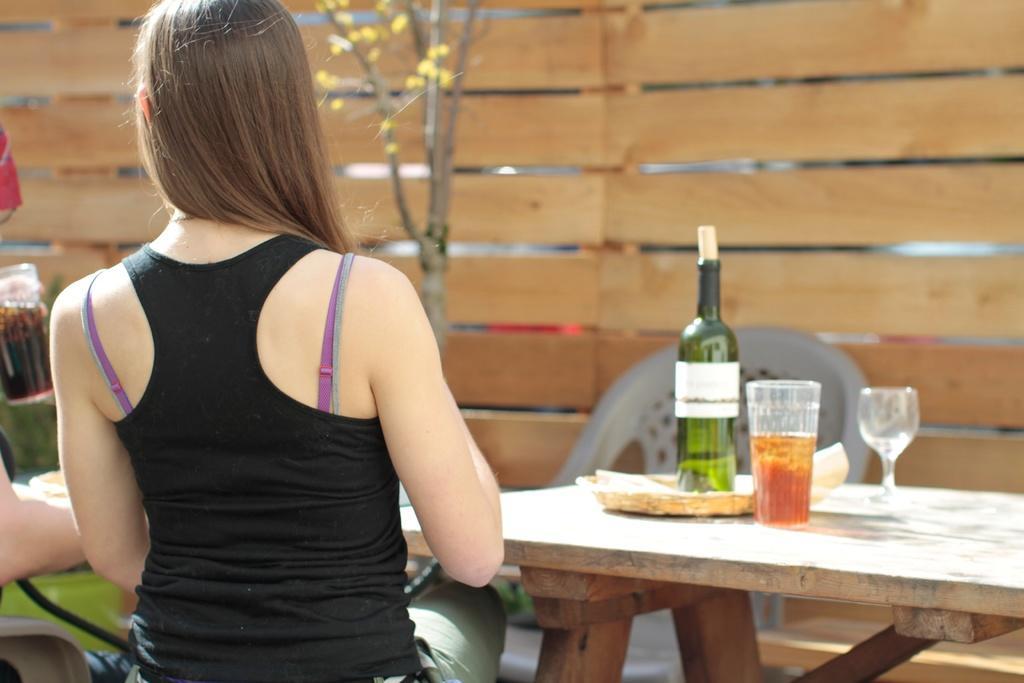Can you describe this image briefly? In this image one woman is sitting on chair and in front of the table and on the table there are one bottle,one glass beside the girl another man is there he could be drinking something and the background is sunny. 